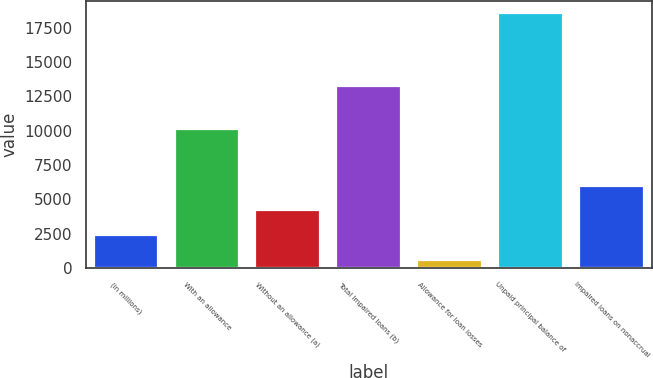<chart> <loc_0><loc_0><loc_500><loc_500><bar_chart><fcel>(in millions)<fcel>With an allowance<fcel>Without an allowance (a)<fcel>Total impaired loans (b)<fcel>Allowance for loan losses<fcel>Unpaid principal balance of<fcel>Impaired loans on nonaccrual<nl><fcel>2387.4<fcel>10100<fcel>4183.8<fcel>13245<fcel>591<fcel>18555<fcel>5980.2<nl></chart> 